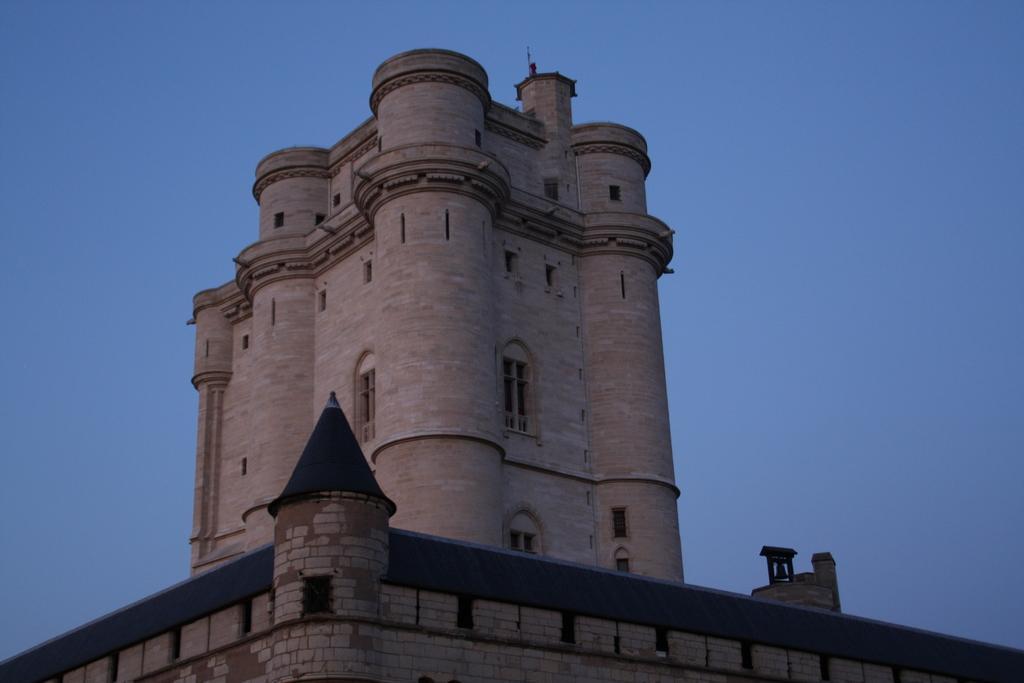Please provide a concise description of this image. In this picture I can see a building, there is the sky in the background. 